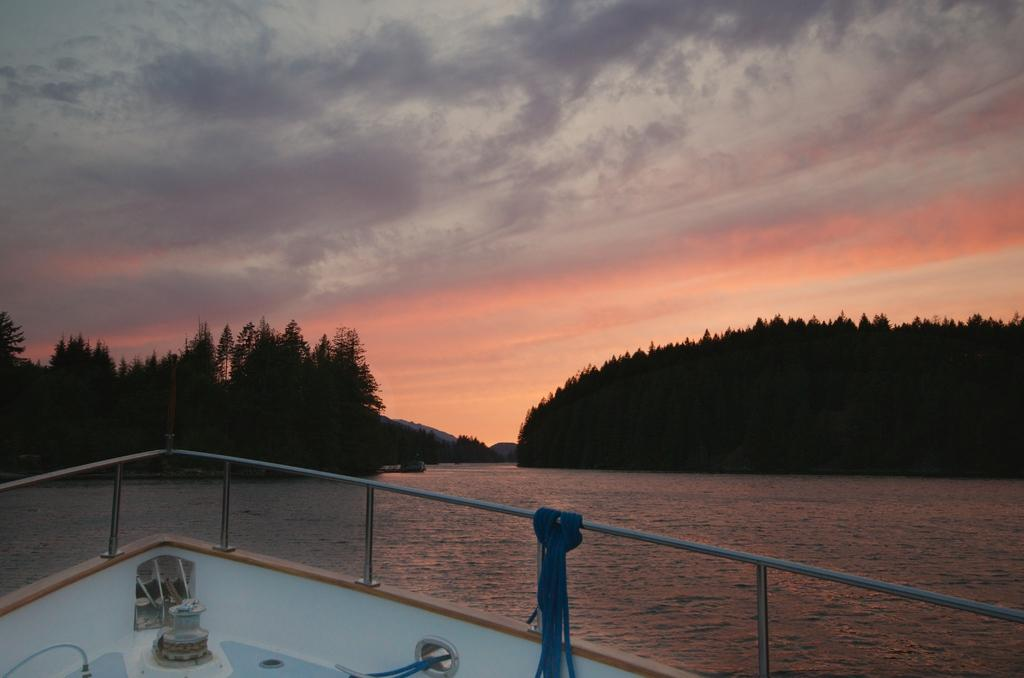What is the main subject of the image? There is a ship in the image. Where is the ship located? The ship is on the water. What type of natural features can be seen in the image? There are trees and mountains visible in the image. Can you see a kite flying in the image? There is no kite visible in the image. How many times does the ship sneeze in the image? Ships do not sneeze, as they are inanimate objects. 